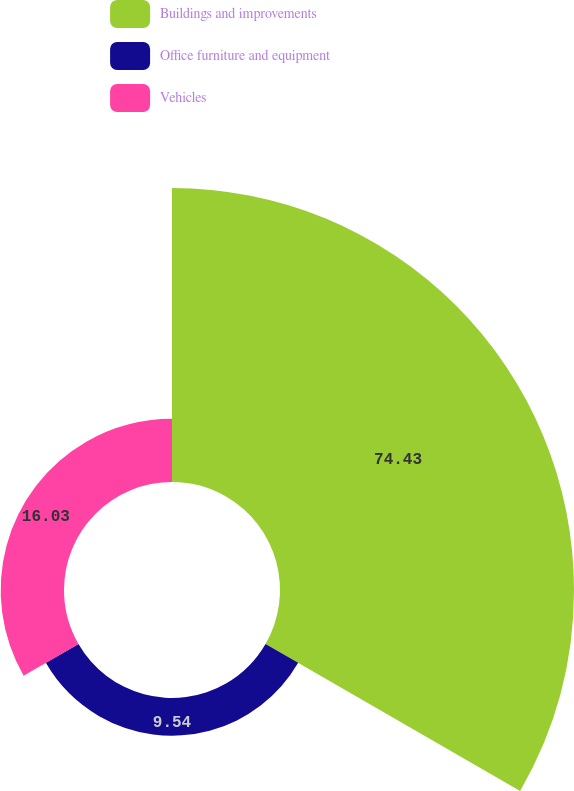Convert chart to OTSL. <chart><loc_0><loc_0><loc_500><loc_500><pie_chart><fcel>Buildings and improvements<fcel>Office furniture and equipment<fcel>Vehicles<nl><fcel>74.43%<fcel>9.54%<fcel>16.03%<nl></chart> 